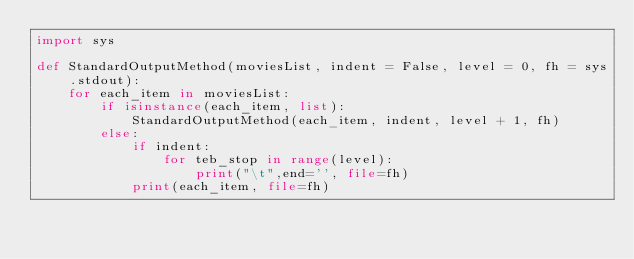<code> <loc_0><loc_0><loc_500><loc_500><_Python_>import sys

def StandardOutputMethod(moviesList, indent = False, level = 0, fh = sys.stdout):
    for each_item in moviesList:
        if isinstance(each_item, list):
            StandardOutputMethod(each_item, indent, level + 1, fh)
        else:
            if indent:
                for teb_stop in range(level):
                    print("\t",end='', file=fh)
            print(each_item, file=fh)
</code> 